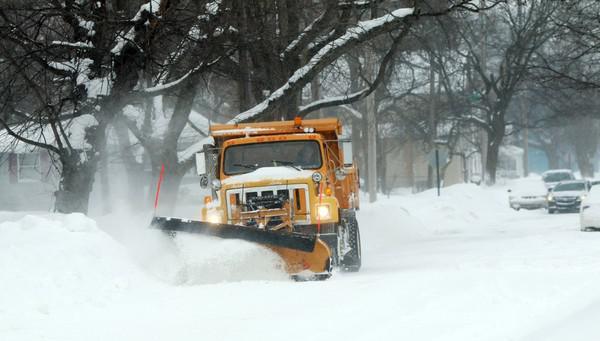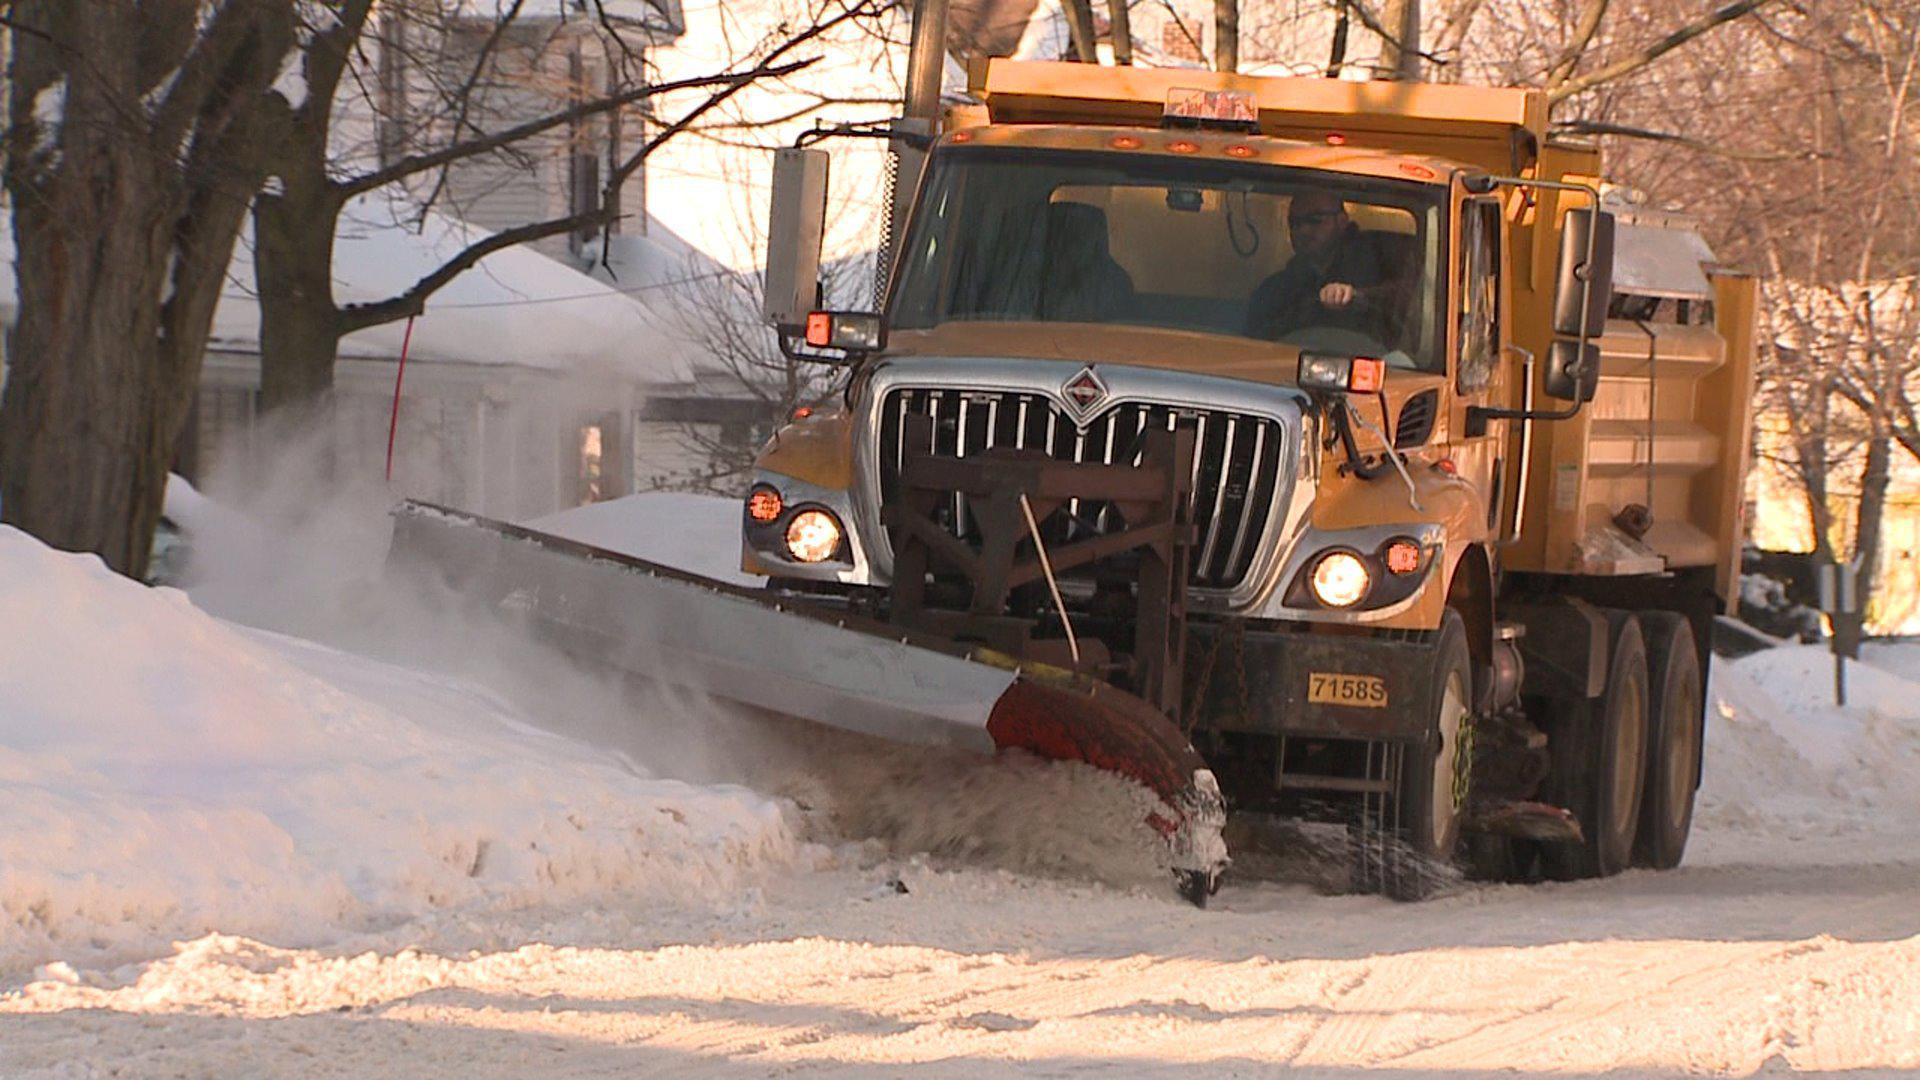The first image is the image on the left, the second image is the image on the right. Analyze the images presented: Is the assertion "Both plows are facing toward the bottom right and plowing snow." valid? Answer yes or no. Yes. 